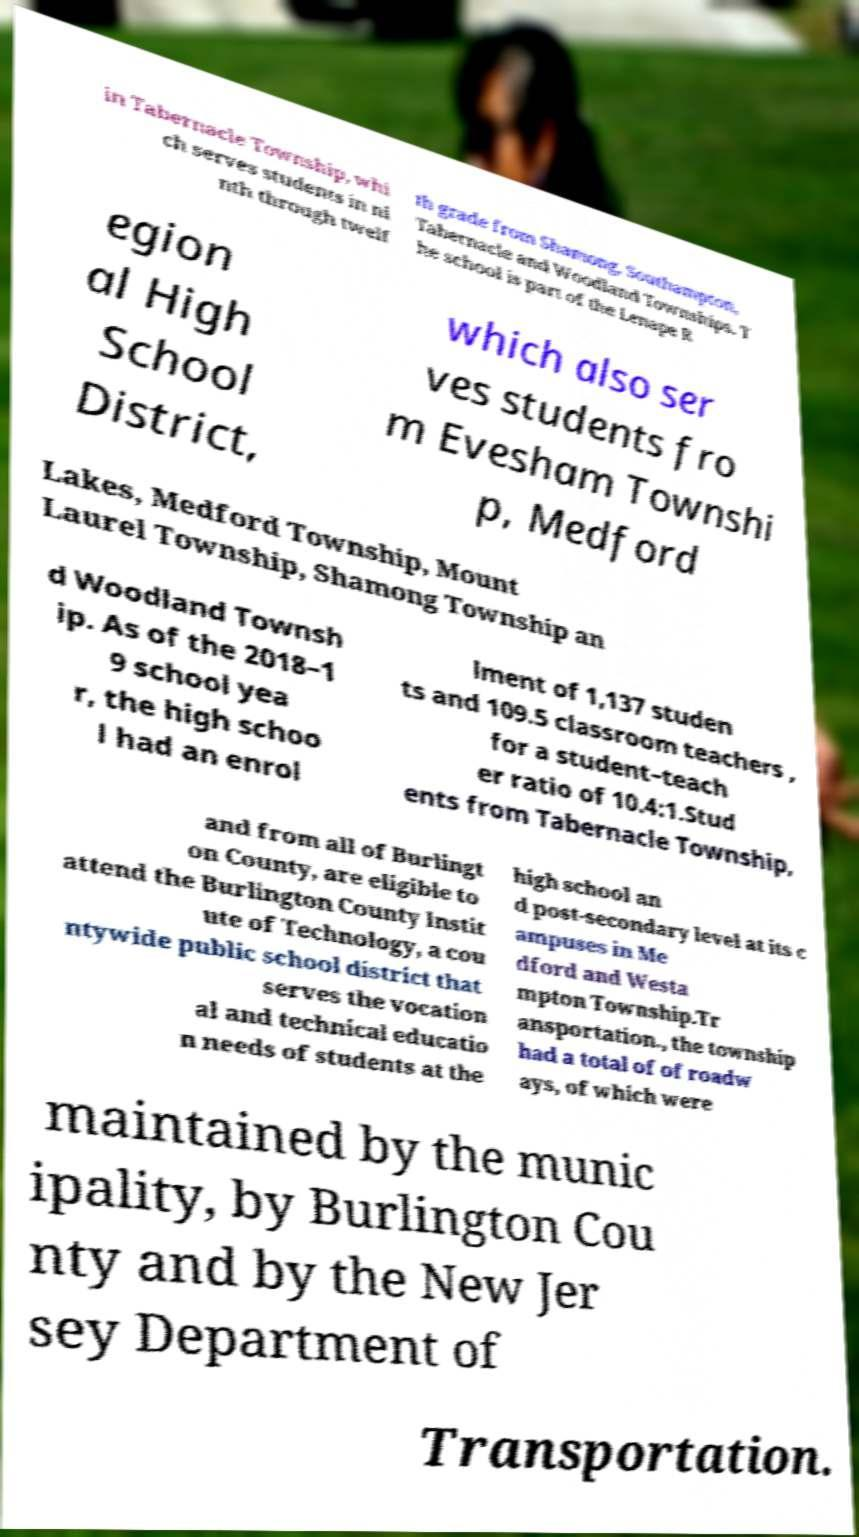Could you extract and type out the text from this image? in Tabernacle Township, whi ch serves students in ni nth through twelf th grade from Shamong, Southampton, Tabernacle and Woodland Townships. T he school is part of the Lenape R egion al High School District, which also ser ves students fro m Evesham Townshi p, Medford Lakes, Medford Township, Mount Laurel Township, Shamong Township an d Woodland Townsh ip. As of the 2018–1 9 school yea r, the high schoo l had an enrol lment of 1,137 studen ts and 109.5 classroom teachers , for a student–teach er ratio of 10.4:1.Stud ents from Tabernacle Township, and from all of Burlingt on County, are eligible to attend the Burlington County Instit ute of Technology, a cou ntywide public school district that serves the vocation al and technical educatio n needs of students at the high school an d post-secondary level at its c ampuses in Me dford and Westa mpton Township.Tr ansportation., the township had a total of of roadw ays, of which were maintained by the munic ipality, by Burlington Cou nty and by the New Jer sey Department of Transportation. 